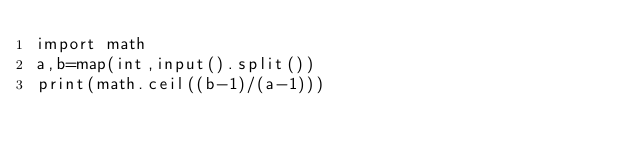Convert code to text. <code><loc_0><loc_0><loc_500><loc_500><_Python_>import math
a,b=map(int,input().split())
print(math.ceil((b-1)/(a-1)))
</code> 